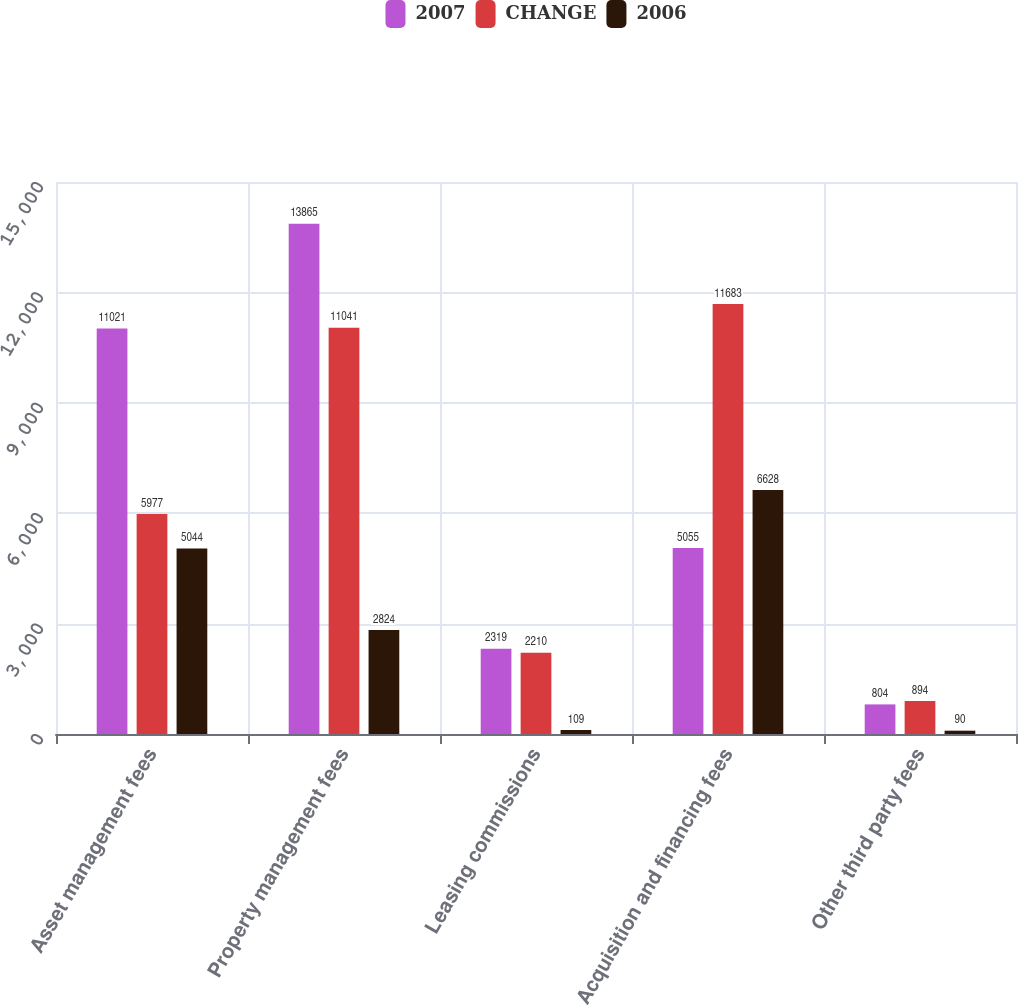<chart> <loc_0><loc_0><loc_500><loc_500><stacked_bar_chart><ecel><fcel>Asset management fees<fcel>Property management fees<fcel>Leasing commissions<fcel>Acquisition and financing fees<fcel>Other third party fees<nl><fcel>2007<fcel>11021<fcel>13865<fcel>2319<fcel>5055<fcel>804<nl><fcel>CHANGE<fcel>5977<fcel>11041<fcel>2210<fcel>11683<fcel>894<nl><fcel>2006<fcel>5044<fcel>2824<fcel>109<fcel>6628<fcel>90<nl></chart> 